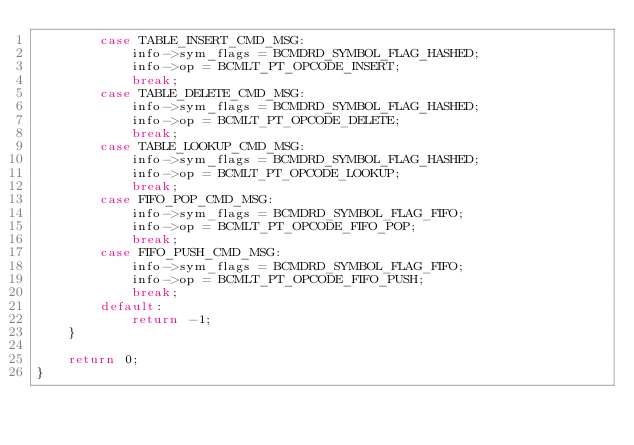<code> <loc_0><loc_0><loc_500><loc_500><_C_>        case TABLE_INSERT_CMD_MSG:
            info->sym_flags = BCMDRD_SYMBOL_FLAG_HASHED;
            info->op = BCMLT_PT_OPCODE_INSERT;
            break;
        case TABLE_DELETE_CMD_MSG:
            info->sym_flags = BCMDRD_SYMBOL_FLAG_HASHED;
            info->op = BCMLT_PT_OPCODE_DELETE;
            break;
        case TABLE_LOOKUP_CMD_MSG:
            info->sym_flags = BCMDRD_SYMBOL_FLAG_HASHED;
            info->op = BCMLT_PT_OPCODE_LOOKUP;
            break;
        case FIFO_POP_CMD_MSG:
            info->sym_flags = BCMDRD_SYMBOL_FLAG_FIFO;
            info->op = BCMLT_PT_OPCODE_FIFO_POP;
            break;
        case FIFO_PUSH_CMD_MSG:
            info->sym_flags = BCMDRD_SYMBOL_FLAG_FIFO;
            info->op = BCMLT_PT_OPCODE_FIFO_PUSH;
            break;
        default:
            return -1;
    }

    return 0;
}

</code> 